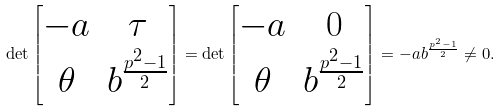Convert formula to latex. <formula><loc_0><loc_0><loc_500><loc_500>\det \left [ \begin{matrix} - a & \tau \\ \theta & b ^ { \frac { p ^ { 2 } - 1 } { 2 } } \end{matrix} \right ] = \det \left [ \begin{matrix} - a & 0 \\ \theta & b ^ { \frac { p ^ { 2 } - 1 } { 2 } } \end{matrix} \right ] = - a b ^ { \frac { p ^ { 2 } - 1 } { 2 } } \ne 0 .</formula> 